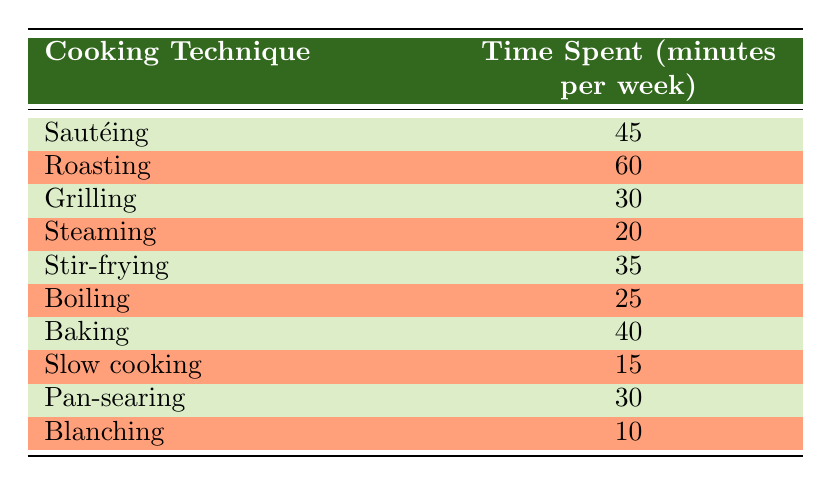What cooking technique takes the most time per week? Referring to the table, the cooking technique with the highest time spent is Roasting at 60 minutes per week.
Answer: Roasting How much time is spent on Steaming? The table shows that Steaming takes 20 minutes per week.
Answer: 20 What is the total time spent on Grilling and Baking combined? From the table, Grilling takes 30 minutes and Baking takes 40 minutes. Adding these together: 30 + 40 = 70.
Answer: 70 Is the time spent on Pan-searing more than that on Blanching? According to the table, Pan-searing takes 30 minutes while Blanching takes 10 minutes. 30 is greater than 10, so yes.
Answer: Yes What is the average time spent on all cooking techniques listed? To find the average, first sum the time spent on all techniques: 45 + 60 + 30 + 20 + 35 + 25 + 40 + 15 + 30 + 10 = 370. There are 10 techniques, so the average is 370 / 10 = 37.
Answer: 37 Which two cooking techniques require the least time combined? The two techniques with the least time are Slow cooking at 15 minutes and Blanching at 10 minutes. Adding these gives: 15 + 10 = 25.
Answer: 25 Does Sautéing take less time than Stir-frying? The table shows Sautéing takes 45 minutes and Stir-frying takes 35 minutes. Since 45 is greater than 35, the statement is false.
Answer: No What is the difference in time spent between Baking and Boiling? Baking takes 40 minutes and Boiling takes 25 minutes. The difference is 40 - 25 = 15 minutes.
Answer: 15 What is the total time spent on all cooking techniques excluding Slow cooking? Adding all the times except Slow cooking: 45 + 60 + 30 + 20 + 35 + 25 + 40 + 30 + 10 = 355.
Answer: 355 